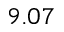<formula> <loc_0><loc_0><loc_500><loc_500>9 . 0 7</formula> 